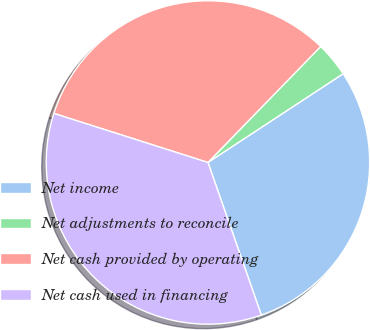<chart> <loc_0><loc_0><loc_500><loc_500><pie_chart><fcel>Net income<fcel>Net adjustments to reconcile<fcel>Net cash provided by operating<fcel>Net cash used in financing<nl><fcel>28.89%<fcel>3.48%<fcel>32.37%<fcel>35.26%<nl></chart> 